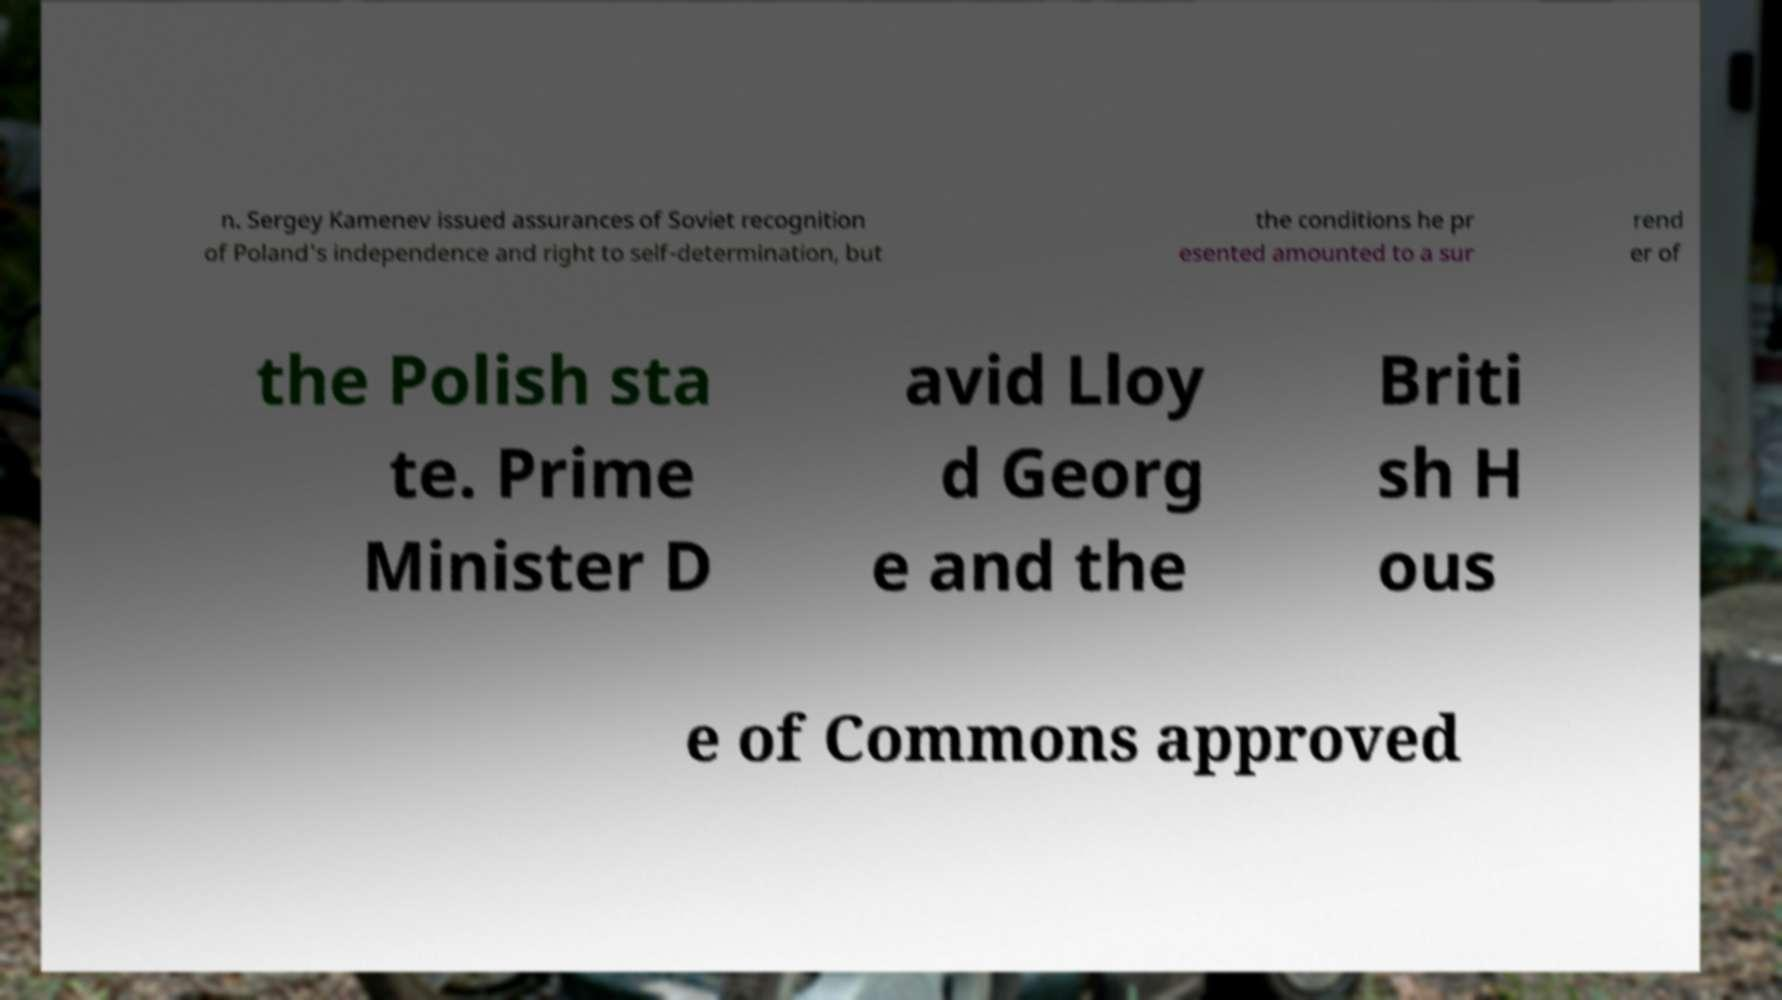What messages or text are displayed in this image? I need them in a readable, typed format. n. Sergey Kamenev issued assurances of Soviet recognition of Poland's independence and right to self-determination, but the conditions he pr esented amounted to a sur rend er of the Polish sta te. Prime Minister D avid Lloy d Georg e and the Briti sh H ous e of Commons approved 